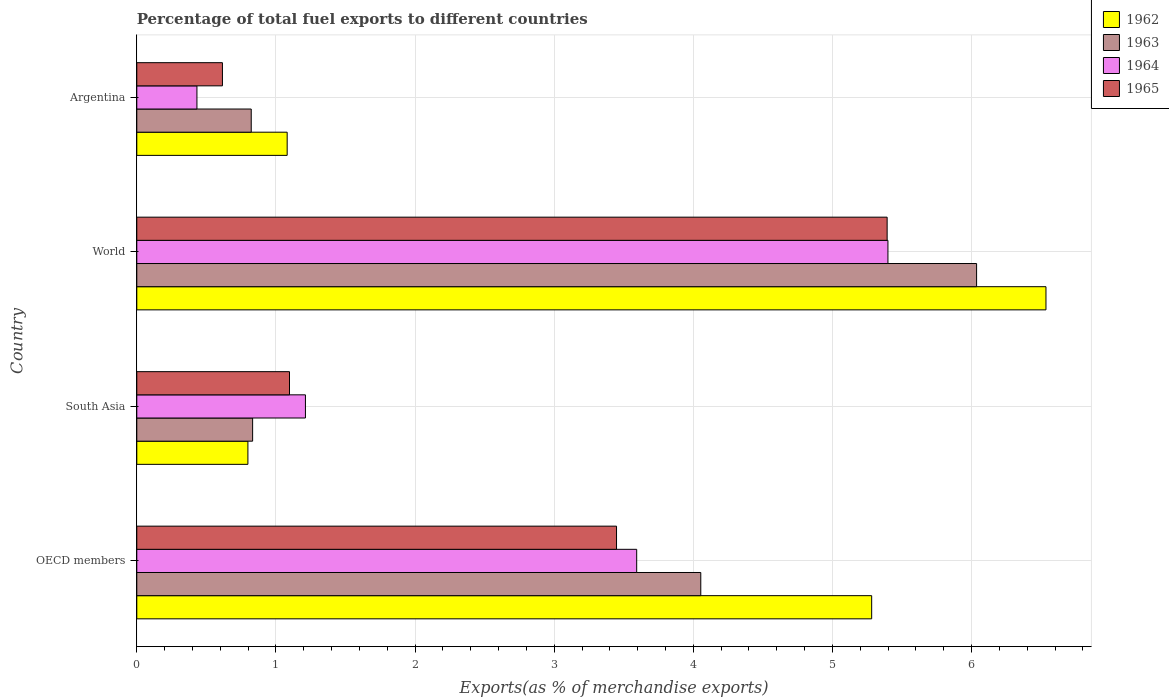How many different coloured bars are there?
Keep it short and to the point. 4. What is the label of the 3rd group of bars from the top?
Give a very brief answer. South Asia. What is the percentage of exports to different countries in 1964 in South Asia?
Your answer should be very brief. 1.21. Across all countries, what is the maximum percentage of exports to different countries in 1964?
Provide a short and direct response. 5.4. Across all countries, what is the minimum percentage of exports to different countries in 1964?
Give a very brief answer. 0.43. In which country was the percentage of exports to different countries in 1962 maximum?
Provide a short and direct response. World. In which country was the percentage of exports to different countries in 1965 minimum?
Provide a short and direct response. Argentina. What is the total percentage of exports to different countries in 1963 in the graph?
Provide a succinct answer. 11.74. What is the difference between the percentage of exports to different countries in 1963 in Argentina and that in South Asia?
Your answer should be very brief. -0.01. What is the difference between the percentage of exports to different countries in 1965 in Argentina and the percentage of exports to different countries in 1964 in World?
Your answer should be compact. -4.78. What is the average percentage of exports to different countries in 1962 per country?
Give a very brief answer. 3.42. What is the difference between the percentage of exports to different countries in 1965 and percentage of exports to different countries in 1962 in World?
Provide a succinct answer. -1.14. In how many countries, is the percentage of exports to different countries in 1965 greater than 4.4 %?
Ensure brevity in your answer.  1. What is the ratio of the percentage of exports to different countries in 1962 in Argentina to that in South Asia?
Make the answer very short. 1.35. What is the difference between the highest and the second highest percentage of exports to different countries in 1963?
Your answer should be compact. 1.98. What is the difference between the highest and the lowest percentage of exports to different countries in 1963?
Your answer should be very brief. 5.21. In how many countries, is the percentage of exports to different countries in 1964 greater than the average percentage of exports to different countries in 1964 taken over all countries?
Offer a terse response. 2. Is it the case that in every country, the sum of the percentage of exports to different countries in 1963 and percentage of exports to different countries in 1964 is greater than the sum of percentage of exports to different countries in 1965 and percentage of exports to different countries in 1962?
Offer a terse response. No. What does the 2nd bar from the bottom in World represents?
Make the answer very short. 1963. How many bars are there?
Provide a succinct answer. 16. Are all the bars in the graph horizontal?
Give a very brief answer. Yes. Does the graph contain any zero values?
Keep it short and to the point. No. Does the graph contain grids?
Offer a terse response. Yes. Where does the legend appear in the graph?
Ensure brevity in your answer.  Top right. What is the title of the graph?
Your response must be concise. Percentage of total fuel exports to different countries. Does "2010" appear as one of the legend labels in the graph?
Provide a succinct answer. No. What is the label or title of the X-axis?
Offer a terse response. Exports(as % of merchandise exports). What is the label or title of the Y-axis?
Provide a succinct answer. Country. What is the Exports(as % of merchandise exports) of 1962 in OECD members?
Ensure brevity in your answer.  5.28. What is the Exports(as % of merchandise exports) in 1963 in OECD members?
Make the answer very short. 4.05. What is the Exports(as % of merchandise exports) in 1964 in OECD members?
Your answer should be very brief. 3.59. What is the Exports(as % of merchandise exports) of 1965 in OECD members?
Your answer should be very brief. 3.45. What is the Exports(as % of merchandise exports) of 1962 in South Asia?
Keep it short and to the point. 0.8. What is the Exports(as % of merchandise exports) of 1963 in South Asia?
Your response must be concise. 0.83. What is the Exports(as % of merchandise exports) of 1964 in South Asia?
Your response must be concise. 1.21. What is the Exports(as % of merchandise exports) of 1965 in South Asia?
Make the answer very short. 1.1. What is the Exports(as % of merchandise exports) of 1962 in World?
Ensure brevity in your answer.  6.53. What is the Exports(as % of merchandise exports) of 1963 in World?
Your response must be concise. 6.04. What is the Exports(as % of merchandise exports) of 1964 in World?
Offer a very short reply. 5.4. What is the Exports(as % of merchandise exports) of 1965 in World?
Ensure brevity in your answer.  5.39. What is the Exports(as % of merchandise exports) of 1962 in Argentina?
Provide a short and direct response. 1.08. What is the Exports(as % of merchandise exports) in 1963 in Argentina?
Offer a terse response. 0.82. What is the Exports(as % of merchandise exports) of 1964 in Argentina?
Provide a short and direct response. 0.43. What is the Exports(as % of merchandise exports) of 1965 in Argentina?
Your answer should be very brief. 0.62. Across all countries, what is the maximum Exports(as % of merchandise exports) of 1962?
Offer a terse response. 6.53. Across all countries, what is the maximum Exports(as % of merchandise exports) in 1963?
Provide a succinct answer. 6.04. Across all countries, what is the maximum Exports(as % of merchandise exports) of 1964?
Ensure brevity in your answer.  5.4. Across all countries, what is the maximum Exports(as % of merchandise exports) of 1965?
Provide a succinct answer. 5.39. Across all countries, what is the minimum Exports(as % of merchandise exports) in 1962?
Provide a short and direct response. 0.8. Across all countries, what is the minimum Exports(as % of merchandise exports) of 1963?
Your answer should be very brief. 0.82. Across all countries, what is the minimum Exports(as % of merchandise exports) in 1964?
Provide a short and direct response. 0.43. Across all countries, what is the minimum Exports(as % of merchandise exports) in 1965?
Make the answer very short. 0.62. What is the total Exports(as % of merchandise exports) of 1962 in the graph?
Give a very brief answer. 13.7. What is the total Exports(as % of merchandise exports) of 1963 in the graph?
Give a very brief answer. 11.74. What is the total Exports(as % of merchandise exports) in 1964 in the graph?
Provide a succinct answer. 10.64. What is the total Exports(as % of merchandise exports) of 1965 in the graph?
Your answer should be very brief. 10.55. What is the difference between the Exports(as % of merchandise exports) in 1962 in OECD members and that in South Asia?
Keep it short and to the point. 4.48. What is the difference between the Exports(as % of merchandise exports) of 1963 in OECD members and that in South Asia?
Offer a terse response. 3.22. What is the difference between the Exports(as % of merchandise exports) in 1964 in OECD members and that in South Asia?
Your answer should be compact. 2.38. What is the difference between the Exports(as % of merchandise exports) in 1965 in OECD members and that in South Asia?
Offer a very short reply. 2.35. What is the difference between the Exports(as % of merchandise exports) of 1962 in OECD members and that in World?
Your answer should be compact. -1.25. What is the difference between the Exports(as % of merchandise exports) in 1963 in OECD members and that in World?
Provide a succinct answer. -1.98. What is the difference between the Exports(as % of merchandise exports) of 1964 in OECD members and that in World?
Your answer should be compact. -1.81. What is the difference between the Exports(as % of merchandise exports) of 1965 in OECD members and that in World?
Ensure brevity in your answer.  -1.94. What is the difference between the Exports(as % of merchandise exports) in 1962 in OECD members and that in Argentina?
Your answer should be very brief. 4.2. What is the difference between the Exports(as % of merchandise exports) in 1963 in OECD members and that in Argentina?
Your answer should be very brief. 3.23. What is the difference between the Exports(as % of merchandise exports) of 1964 in OECD members and that in Argentina?
Provide a short and direct response. 3.16. What is the difference between the Exports(as % of merchandise exports) in 1965 in OECD members and that in Argentina?
Offer a very short reply. 2.83. What is the difference between the Exports(as % of merchandise exports) of 1962 in South Asia and that in World?
Your answer should be compact. -5.74. What is the difference between the Exports(as % of merchandise exports) of 1963 in South Asia and that in World?
Keep it short and to the point. -5.2. What is the difference between the Exports(as % of merchandise exports) in 1964 in South Asia and that in World?
Give a very brief answer. -4.19. What is the difference between the Exports(as % of merchandise exports) in 1965 in South Asia and that in World?
Keep it short and to the point. -4.3. What is the difference between the Exports(as % of merchandise exports) in 1962 in South Asia and that in Argentina?
Make the answer very short. -0.28. What is the difference between the Exports(as % of merchandise exports) of 1963 in South Asia and that in Argentina?
Offer a terse response. 0.01. What is the difference between the Exports(as % of merchandise exports) of 1964 in South Asia and that in Argentina?
Your answer should be compact. 0.78. What is the difference between the Exports(as % of merchandise exports) of 1965 in South Asia and that in Argentina?
Keep it short and to the point. 0.48. What is the difference between the Exports(as % of merchandise exports) in 1962 in World and that in Argentina?
Your answer should be compact. 5.45. What is the difference between the Exports(as % of merchandise exports) of 1963 in World and that in Argentina?
Your answer should be compact. 5.21. What is the difference between the Exports(as % of merchandise exports) of 1964 in World and that in Argentina?
Ensure brevity in your answer.  4.97. What is the difference between the Exports(as % of merchandise exports) of 1965 in World and that in Argentina?
Your answer should be very brief. 4.78. What is the difference between the Exports(as % of merchandise exports) in 1962 in OECD members and the Exports(as % of merchandise exports) in 1963 in South Asia?
Your response must be concise. 4.45. What is the difference between the Exports(as % of merchandise exports) in 1962 in OECD members and the Exports(as % of merchandise exports) in 1964 in South Asia?
Provide a succinct answer. 4.07. What is the difference between the Exports(as % of merchandise exports) of 1962 in OECD members and the Exports(as % of merchandise exports) of 1965 in South Asia?
Make the answer very short. 4.18. What is the difference between the Exports(as % of merchandise exports) of 1963 in OECD members and the Exports(as % of merchandise exports) of 1964 in South Asia?
Your answer should be very brief. 2.84. What is the difference between the Exports(as % of merchandise exports) in 1963 in OECD members and the Exports(as % of merchandise exports) in 1965 in South Asia?
Give a very brief answer. 2.96. What is the difference between the Exports(as % of merchandise exports) of 1964 in OECD members and the Exports(as % of merchandise exports) of 1965 in South Asia?
Ensure brevity in your answer.  2.5. What is the difference between the Exports(as % of merchandise exports) of 1962 in OECD members and the Exports(as % of merchandise exports) of 1963 in World?
Make the answer very short. -0.75. What is the difference between the Exports(as % of merchandise exports) of 1962 in OECD members and the Exports(as % of merchandise exports) of 1964 in World?
Provide a succinct answer. -0.12. What is the difference between the Exports(as % of merchandise exports) of 1962 in OECD members and the Exports(as % of merchandise exports) of 1965 in World?
Keep it short and to the point. -0.11. What is the difference between the Exports(as % of merchandise exports) of 1963 in OECD members and the Exports(as % of merchandise exports) of 1964 in World?
Make the answer very short. -1.35. What is the difference between the Exports(as % of merchandise exports) of 1963 in OECD members and the Exports(as % of merchandise exports) of 1965 in World?
Keep it short and to the point. -1.34. What is the difference between the Exports(as % of merchandise exports) of 1964 in OECD members and the Exports(as % of merchandise exports) of 1965 in World?
Offer a terse response. -1.8. What is the difference between the Exports(as % of merchandise exports) of 1962 in OECD members and the Exports(as % of merchandise exports) of 1963 in Argentina?
Provide a succinct answer. 4.46. What is the difference between the Exports(as % of merchandise exports) of 1962 in OECD members and the Exports(as % of merchandise exports) of 1964 in Argentina?
Ensure brevity in your answer.  4.85. What is the difference between the Exports(as % of merchandise exports) of 1962 in OECD members and the Exports(as % of merchandise exports) of 1965 in Argentina?
Provide a succinct answer. 4.67. What is the difference between the Exports(as % of merchandise exports) of 1963 in OECD members and the Exports(as % of merchandise exports) of 1964 in Argentina?
Make the answer very short. 3.62. What is the difference between the Exports(as % of merchandise exports) in 1963 in OECD members and the Exports(as % of merchandise exports) in 1965 in Argentina?
Ensure brevity in your answer.  3.44. What is the difference between the Exports(as % of merchandise exports) of 1964 in OECD members and the Exports(as % of merchandise exports) of 1965 in Argentina?
Make the answer very short. 2.98. What is the difference between the Exports(as % of merchandise exports) in 1962 in South Asia and the Exports(as % of merchandise exports) in 1963 in World?
Make the answer very short. -5.24. What is the difference between the Exports(as % of merchandise exports) of 1962 in South Asia and the Exports(as % of merchandise exports) of 1964 in World?
Make the answer very short. -4.6. What is the difference between the Exports(as % of merchandise exports) of 1962 in South Asia and the Exports(as % of merchandise exports) of 1965 in World?
Make the answer very short. -4.59. What is the difference between the Exports(as % of merchandise exports) of 1963 in South Asia and the Exports(as % of merchandise exports) of 1964 in World?
Keep it short and to the point. -4.57. What is the difference between the Exports(as % of merchandise exports) of 1963 in South Asia and the Exports(as % of merchandise exports) of 1965 in World?
Keep it short and to the point. -4.56. What is the difference between the Exports(as % of merchandise exports) of 1964 in South Asia and the Exports(as % of merchandise exports) of 1965 in World?
Give a very brief answer. -4.18. What is the difference between the Exports(as % of merchandise exports) in 1962 in South Asia and the Exports(as % of merchandise exports) in 1963 in Argentina?
Your answer should be very brief. -0.02. What is the difference between the Exports(as % of merchandise exports) of 1962 in South Asia and the Exports(as % of merchandise exports) of 1964 in Argentina?
Make the answer very short. 0.37. What is the difference between the Exports(as % of merchandise exports) of 1962 in South Asia and the Exports(as % of merchandise exports) of 1965 in Argentina?
Provide a succinct answer. 0.18. What is the difference between the Exports(as % of merchandise exports) of 1963 in South Asia and the Exports(as % of merchandise exports) of 1964 in Argentina?
Your answer should be compact. 0.4. What is the difference between the Exports(as % of merchandise exports) in 1963 in South Asia and the Exports(as % of merchandise exports) in 1965 in Argentina?
Your answer should be compact. 0.22. What is the difference between the Exports(as % of merchandise exports) in 1964 in South Asia and the Exports(as % of merchandise exports) in 1965 in Argentina?
Your answer should be very brief. 0.6. What is the difference between the Exports(as % of merchandise exports) in 1962 in World and the Exports(as % of merchandise exports) in 1963 in Argentina?
Your answer should be compact. 5.71. What is the difference between the Exports(as % of merchandise exports) of 1962 in World and the Exports(as % of merchandise exports) of 1964 in Argentina?
Keep it short and to the point. 6.1. What is the difference between the Exports(as % of merchandise exports) in 1962 in World and the Exports(as % of merchandise exports) in 1965 in Argentina?
Your answer should be very brief. 5.92. What is the difference between the Exports(as % of merchandise exports) in 1963 in World and the Exports(as % of merchandise exports) in 1964 in Argentina?
Ensure brevity in your answer.  5.6. What is the difference between the Exports(as % of merchandise exports) of 1963 in World and the Exports(as % of merchandise exports) of 1965 in Argentina?
Your response must be concise. 5.42. What is the difference between the Exports(as % of merchandise exports) of 1964 in World and the Exports(as % of merchandise exports) of 1965 in Argentina?
Your response must be concise. 4.78. What is the average Exports(as % of merchandise exports) of 1962 per country?
Your answer should be very brief. 3.42. What is the average Exports(as % of merchandise exports) in 1963 per country?
Keep it short and to the point. 2.94. What is the average Exports(as % of merchandise exports) in 1964 per country?
Ensure brevity in your answer.  2.66. What is the average Exports(as % of merchandise exports) in 1965 per country?
Your response must be concise. 2.64. What is the difference between the Exports(as % of merchandise exports) of 1962 and Exports(as % of merchandise exports) of 1963 in OECD members?
Your answer should be very brief. 1.23. What is the difference between the Exports(as % of merchandise exports) of 1962 and Exports(as % of merchandise exports) of 1964 in OECD members?
Offer a terse response. 1.69. What is the difference between the Exports(as % of merchandise exports) in 1962 and Exports(as % of merchandise exports) in 1965 in OECD members?
Provide a succinct answer. 1.83. What is the difference between the Exports(as % of merchandise exports) in 1963 and Exports(as % of merchandise exports) in 1964 in OECD members?
Provide a succinct answer. 0.46. What is the difference between the Exports(as % of merchandise exports) in 1963 and Exports(as % of merchandise exports) in 1965 in OECD members?
Your answer should be compact. 0.61. What is the difference between the Exports(as % of merchandise exports) in 1964 and Exports(as % of merchandise exports) in 1965 in OECD members?
Provide a succinct answer. 0.14. What is the difference between the Exports(as % of merchandise exports) of 1962 and Exports(as % of merchandise exports) of 1963 in South Asia?
Your response must be concise. -0.03. What is the difference between the Exports(as % of merchandise exports) in 1962 and Exports(as % of merchandise exports) in 1964 in South Asia?
Keep it short and to the point. -0.41. What is the difference between the Exports(as % of merchandise exports) of 1962 and Exports(as % of merchandise exports) of 1965 in South Asia?
Offer a terse response. -0.3. What is the difference between the Exports(as % of merchandise exports) of 1963 and Exports(as % of merchandise exports) of 1964 in South Asia?
Offer a very short reply. -0.38. What is the difference between the Exports(as % of merchandise exports) in 1963 and Exports(as % of merchandise exports) in 1965 in South Asia?
Ensure brevity in your answer.  -0.27. What is the difference between the Exports(as % of merchandise exports) of 1964 and Exports(as % of merchandise exports) of 1965 in South Asia?
Your answer should be very brief. 0.11. What is the difference between the Exports(as % of merchandise exports) in 1962 and Exports(as % of merchandise exports) in 1963 in World?
Provide a short and direct response. 0.5. What is the difference between the Exports(as % of merchandise exports) of 1962 and Exports(as % of merchandise exports) of 1964 in World?
Ensure brevity in your answer.  1.14. What is the difference between the Exports(as % of merchandise exports) of 1962 and Exports(as % of merchandise exports) of 1965 in World?
Give a very brief answer. 1.14. What is the difference between the Exports(as % of merchandise exports) in 1963 and Exports(as % of merchandise exports) in 1964 in World?
Your answer should be compact. 0.64. What is the difference between the Exports(as % of merchandise exports) in 1963 and Exports(as % of merchandise exports) in 1965 in World?
Give a very brief answer. 0.64. What is the difference between the Exports(as % of merchandise exports) of 1964 and Exports(as % of merchandise exports) of 1965 in World?
Ensure brevity in your answer.  0.01. What is the difference between the Exports(as % of merchandise exports) of 1962 and Exports(as % of merchandise exports) of 1963 in Argentina?
Keep it short and to the point. 0.26. What is the difference between the Exports(as % of merchandise exports) in 1962 and Exports(as % of merchandise exports) in 1964 in Argentina?
Offer a terse response. 0.65. What is the difference between the Exports(as % of merchandise exports) in 1962 and Exports(as % of merchandise exports) in 1965 in Argentina?
Offer a terse response. 0.47. What is the difference between the Exports(as % of merchandise exports) of 1963 and Exports(as % of merchandise exports) of 1964 in Argentina?
Your answer should be compact. 0.39. What is the difference between the Exports(as % of merchandise exports) of 1963 and Exports(as % of merchandise exports) of 1965 in Argentina?
Ensure brevity in your answer.  0.21. What is the difference between the Exports(as % of merchandise exports) in 1964 and Exports(as % of merchandise exports) in 1965 in Argentina?
Provide a succinct answer. -0.18. What is the ratio of the Exports(as % of merchandise exports) in 1962 in OECD members to that in South Asia?
Give a very brief answer. 6.61. What is the ratio of the Exports(as % of merchandise exports) of 1963 in OECD members to that in South Asia?
Your answer should be compact. 4.87. What is the ratio of the Exports(as % of merchandise exports) in 1964 in OECD members to that in South Asia?
Your response must be concise. 2.96. What is the ratio of the Exports(as % of merchandise exports) of 1965 in OECD members to that in South Asia?
Offer a very short reply. 3.14. What is the ratio of the Exports(as % of merchandise exports) of 1962 in OECD members to that in World?
Keep it short and to the point. 0.81. What is the ratio of the Exports(as % of merchandise exports) of 1963 in OECD members to that in World?
Give a very brief answer. 0.67. What is the ratio of the Exports(as % of merchandise exports) in 1964 in OECD members to that in World?
Offer a terse response. 0.67. What is the ratio of the Exports(as % of merchandise exports) of 1965 in OECD members to that in World?
Give a very brief answer. 0.64. What is the ratio of the Exports(as % of merchandise exports) of 1962 in OECD members to that in Argentina?
Your answer should be compact. 4.89. What is the ratio of the Exports(as % of merchandise exports) in 1963 in OECD members to that in Argentina?
Offer a very short reply. 4.93. What is the ratio of the Exports(as % of merchandise exports) in 1964 in OECD members to that in Argentina?
Keep it short and to the point. 8.31. What is the ratio of the Exports(as % of merchandise exports) in 1965 in OECD members to that in Argentina?
Your answer should be very brief. 5.6. What is the ratio of the Exports(as % of merchandise exports) of 1962 in South Asia to that in World?
Offer a very short reply. 0.12. What is the ratio of the Exports(as % of merchandise exports) of 1963 in South Asia to that in World?
Provide a succinct answer. 0.14. What is the ratio of the Exports(as % of merchandise exports) of 1964 in South Asia to that in World?
Keep it short and to the point. 0.22. What is the ratio of the Exports(as % of merchandise exports) of 1965 in South Asia to that in World?
Ensure brevity in your answer.  0.2. What is the ratio of the Exports(as % of merchandise exports) in 1962 in South Asia to that in Argentina?
Make the answer very short. 0.74. What is the ratio of the Exports(as % of merchandise exports) of 1963 in South Asia to that in Argentina?
Ensure brevity in your answer.  1.01. What is the ratio of the Exports(as % of merchandise exports) of 1964 in South Asia to that in Argentina?
Provide a succinct answer. 2.8. What is the ratio of the Exports(as % of merchandise exports) of 1965 in South Asia to that in Argentina?
Give a very brief answer. 1.78. What is the ratio of the Exports(as % of merchandise exports) in 1962 in World to that in Argentina?
Make the answer very short. 6.05. What is the ratio of the Exports(as % of merchandise exports) of 1963 in World to that in Argentina?
Offer a very short reply. 7.34. What is the ratio of the Exports(as % of merchandise exports) in 1964 in World to that in Argentina?
Offer a terse response. 12.49. What is the ratio of the Exports(as % of merchandise exports) of 1965 in World to that in Argentina?
Offer a terse response. 8.76. What is the difference between the highest and the second highest Exports(as % of merchandise exports) in 1962?
Provide a succinct answer. 1.25. What is the difference between the highest and the second highest Exports(as % of merchandise exports) in 1963?
Provide a short and direct response. 1.98. What is the difference between the highest and the second highest Exports(as % of merchandise exports) of 1964?
Give a very brief answer. 1.81. What is the difference between the highest and the second highest Exports(as % of merchandise exports) of 1965?
Give a very brief answer. 1.94. What is the difference between the highest and the lowest Exports(as % of merchandise exports) in 1962?
Provide a short and direct response. 5.74. What is the difference between the highest and the lowest Exports(as % of merchandise exports) of 1963?
Keep it short and to the point. 5.21. What is the difference between the highest and the lowest Exports(as % of merchandise exports) of 1964?
Offer a very short reply. 4.97. What is the difference between the highest and the lowest Exports(as % of merchandise exports) in 1965?
Offer a very short reply. 4.78. 